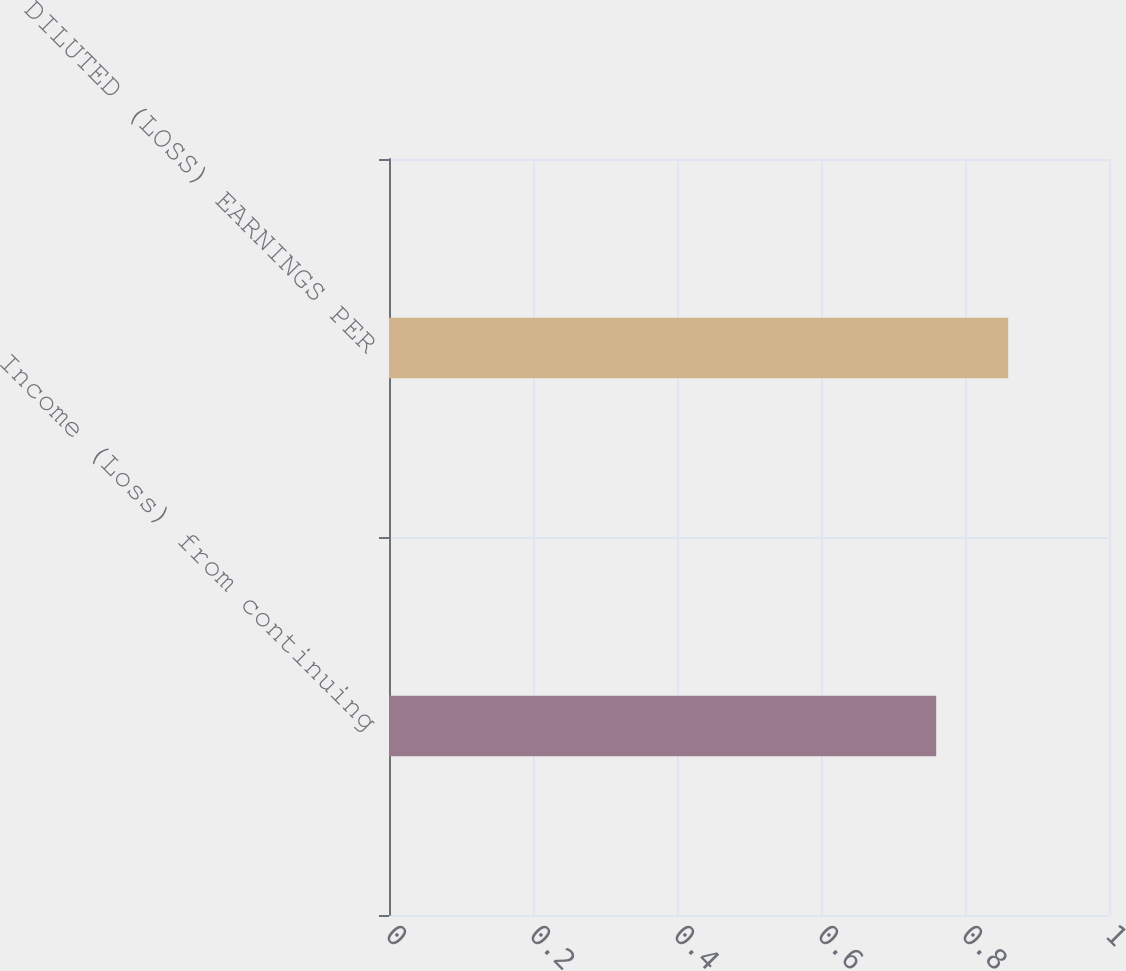Convert chart to OTSL. <chart><loc_0><loc_0><loc_500><loc_500><bar_chart><fcel>Income (Loss) from continuing<fcel>DILUTED (LOSS) EARNINGS PER<nl><fcel>0.76<fcel>0.86<nl></chart> 